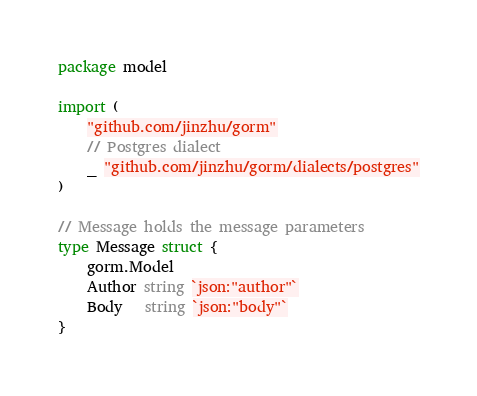Convert code to text. <code><loc_0><loc_0><loc_500><loc_500><_Go_>package model

import (
	"github.com/jinzhu/gorm"
	// Postgres dialect
	_ "github.com/jinzhu/gorm/dialects/postgres"
)

// Message holds the message parameters
type Message struct {
	gorm.Model
	Author string `json:"author"`
	Body   string `json:"body"`
}
</code> 